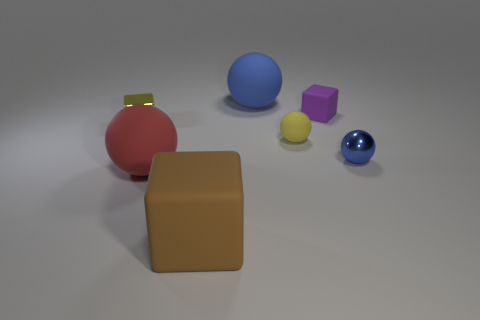Add 2 big matte objects. How many objects exist? 9 Subtract all gray spheres. Subtract all yellow cylinders. How many spheres are left? 4 Subtract all blocks. How many objects are left? 4 Add 7 blue metallic blocks. How many blue metallic blocks exist? 7 Subtract 1 red balls. How many objects are left? 6 Subtract all large green spheres. Subtract all purple matte blocks. How many objects are left? 6 Add 7 tiny yellow balls. How many tiny yellow balls are left? 8 